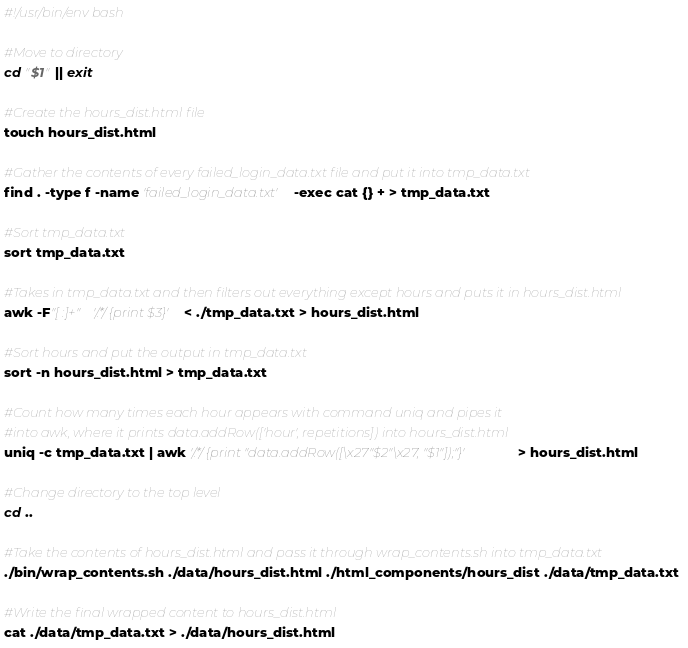Convert code to text. <code><loc_0><loc_0><loc_500><loc_500><_Bash_>#!/usr/bin/env bash

#Move to directory
cd "$1" || exit

#Create the hours_dist.html file
touch hours_dist.html

#Gather the contents of every failed_login_data.txt file and put it into tmp_data.txt
find . -type f -name 'failed_login_data.txt' -exec cat {} + > tmp_data.txt

#Sort tmp_data.txt
sort tmp_data.txt

#Takes in tmp_data.txt and then filters out everything except hours and puts it in hours_dist.html
awk -F"[ :]+" '/.*/ {print $3}'< ./tmp_data.txt > hours_dist.html

#Sort hours and put the output in tmp_data.txt
sort -n hours_dist.html > tmp_data.txt

#Count how many times each hour appears with command uniq and pipes it
#into awk, where it prints data.addRow(['hour', repetitions]) into hours_dist.html
uniq -c tmp_data.txt | awk '/.*/ {print "data.addRow([\x27"$2"\x27, "$1"]);"}' > hours_dist.html

#Change directory to the top level
cd ..

#Take the contents of hours_dist.html and pass it through wrap_contents.sh into tmp_data.txt
./bin/wrap_contents.sh ./data/hours_dist.html ./html_components/hours_dist ./data/tmp_data.txt

#Write the final wrapped content to hours_dist.html
cat ./data/tmp_data.txt > ./data/hours_dist.html
</code> 